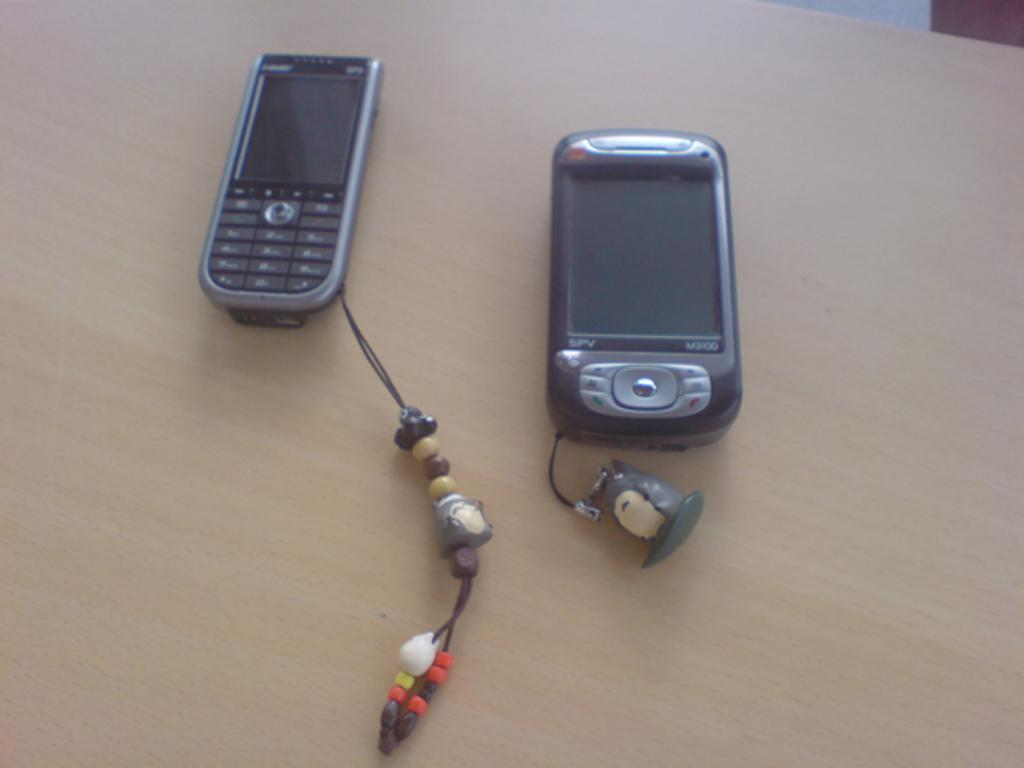What color is the table in the image? The table in the image is cream-colored. What objects are on the table? There are two mobile phones on the table. What type of brick is being used to attack the table in the image? There is no brick or attack present in the image; it only features a cream-colored table and two mobile phones. What kind of loaf is placed on the table in the image? There is no loaf present in the image; it only features a cream-colored table and two mobile phones. 